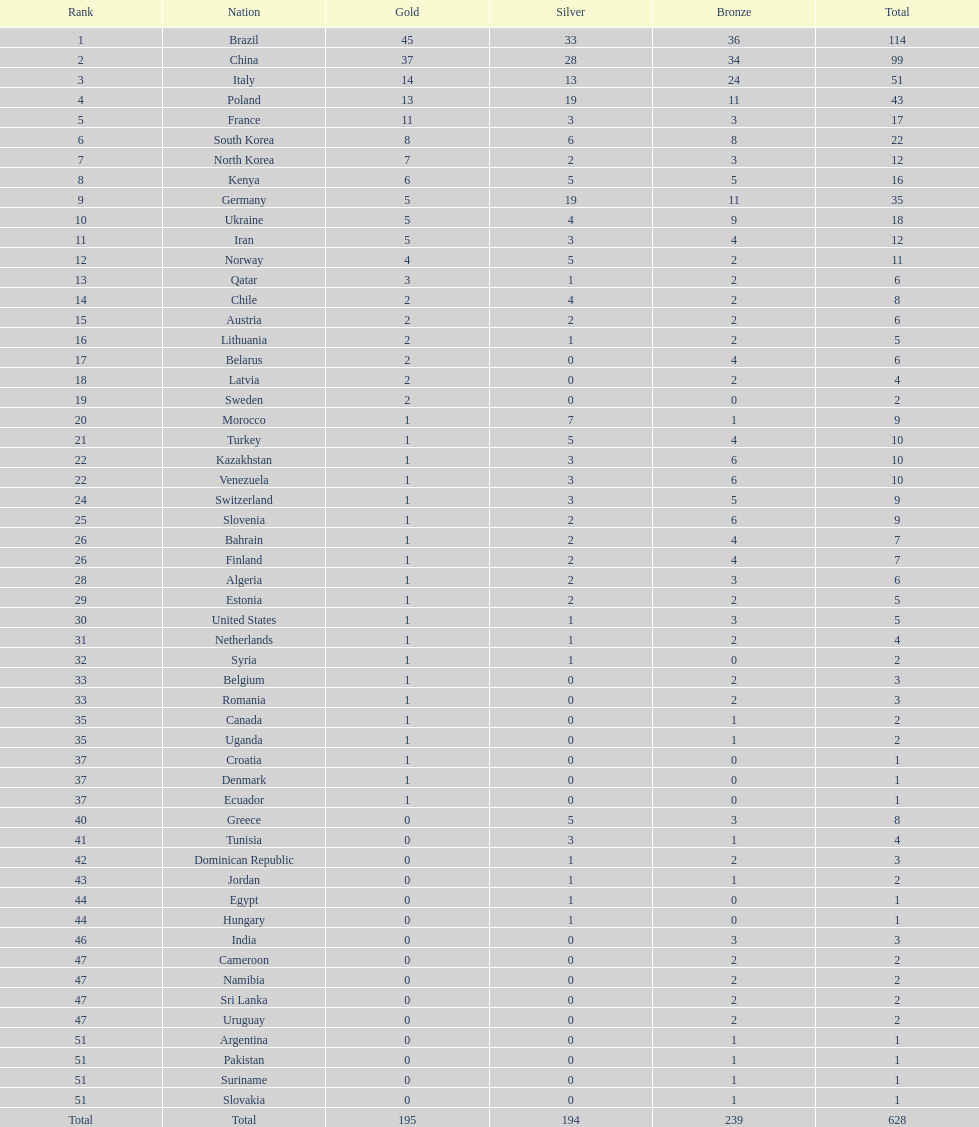Can you give me this table as a dict? {'header': ['Rank', 'Nation', 'Gold', 'Silver', 'Bronze', 'Total'], 'rows': [['1', 'Brazil', '45', '33', '36', '114'], ['2', 'China', '37', '28', '34', '99'], ['3', 'Italy', '14', '13', '24', '51'], ['4', 'Poland', '13', '19', '11', '43'], ['5', 'France', '11', '3', '3', '17'], ['6', 'South Korea', '8', '6', '8', '22'], ['7', 'North Korea', '7', '2', '3', '12'], ['8', 'Kenya', '6', '5', '5', '16'], ['9', 'Germany', '5', '19', '11', '35'], ['10', 'Ukraine', '5', '4', '9', '18'], ['11', 'Iran', '5', '3', '4', '12'], ['12', 'Norway', '4', '5', '2', '11'], ['13', 'Qatar', '3', '1', '2', '6'], ['14', 'Chile', '2', '4', '2', '8'], ['15', 'Austria', '2', '2', '2', '6'], ['16', 'Lithuania', '2', '1', '2', '5'], ['17', 'Belarus', '2', '0', '4', '6'], ['18', 'Latvia', '2', '0', '2', '4'], ['19', 'Sweden', '2', '0', '0', '2'], ['20', 'Morocco', '1', '7', '1', '9'], ['21', 'Turkey', '1', '5', '4', '10'], ['22', 'Kazakhstan', '1', '3', '6', '10'], ['22', 'Venezuela', '1', '3', '6', '10'], ['24', 'Switzerland', '1', '3', '5', '9'], ['25', 'Slovenia', '1', '2', '6', '9'], ['26', 'Bahrain', '1', '2', '4', '7'], ['26', 'Finland', '1', '2', '4', '7'], ['28', 'Algeria', '1', '2', '3', '6'], ['29', 'Estonia', '1', '2', '2', '5'], ['30', 'United States', '1', '1', '3', '5'], ['31', 'Netherlands', '1', '1', '2', '4'], ['32', 'Syria', '1', '1', '0', '2'], ['33', 'Belgium', '1', '0', '2', '3'], ['33', 'Romania', '1', '0', '2', '3'], ['35', 'Canada', '1', '0', '1', '2'], ['35', 'Uganda', '1', '0', '1', '2'], ['37', 'Croatia', '1', '0', '0', '1'], ['37', 'Denmark', '1', '0', '0', '1'], ['37', 'Ecuador', '1', '0', '0', '1'], ['40', 'Greece', '0', '5', '3', '8'], ['41', 'Tunisia', '0', '3', '1', '4'], ['42', 'Dominican Republic', '0', '1', '2', '3'], ['43', 'Jordan', '0', '1', '1', '2'], ['44', 'Egypt', '0', '1', '0', '1'], ['44', 'Hungary', '0', '1', '0', '1'], ['46', 'India', '0', '0', '3', '3'], ['47', 'Cameroon', '0', '0', '2', '2'], ['47', 'Namibia', '0', '0', '2', '2'], ['47', 'Sri Lanka', '0', '0', '2', '2'], ['47', 'Uruguay', '0', '0', '2', '2'], ['51', 'Argentina', '0', '0', '1', '1'], ['51', 'Pakistan', '0', '0', '1', '1'], ['51', 'Suriname', '0', '0', '1', '1'], ['51', 'Slovakia', '0', '0', '1', '1'], ['Total', 'Total', '195', '194', '239', '628']]} Did italy or norway obtain 51 cumulative medals? Italy. 